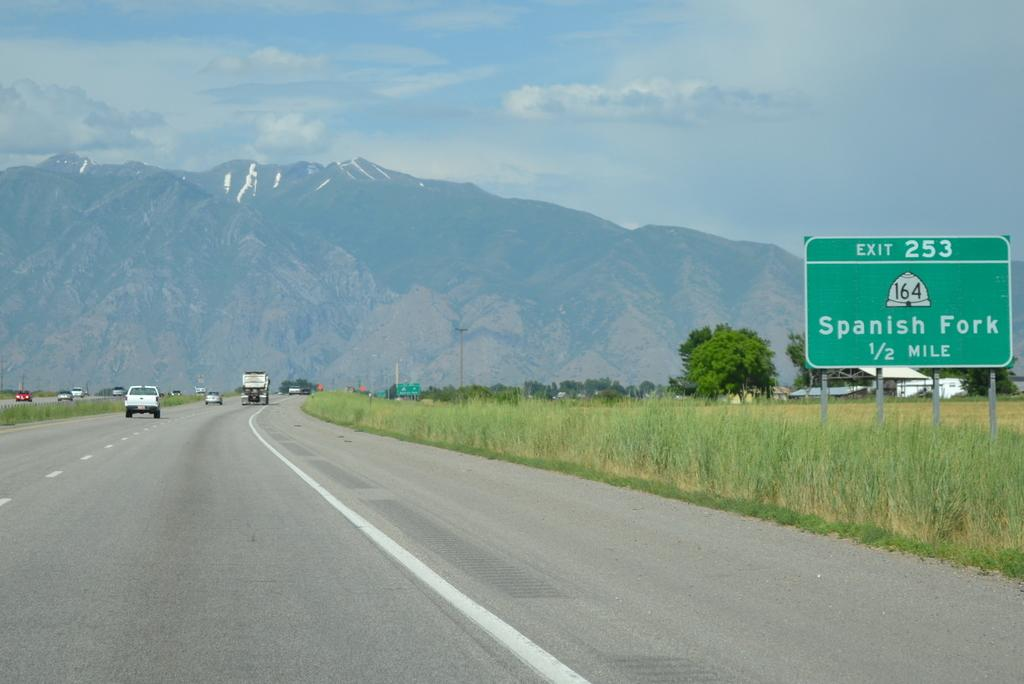<image>
Summarize the visual content of the image. A highway exit sign for Spanish Fork on a road leading to mountains. 